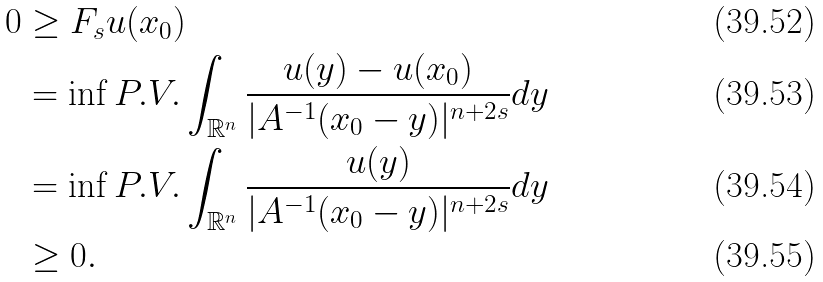<formula> <loc_0><loc_0><loc_500><loc_500>0 & \geq F _ { s } u ( x _ { 0 } ) \\ & = \inf P . V . \int _ { \mathbb { R } ^ { n } } \frac { u ( y ) - u ( x _ { 0 } ) } { | A ^ { - 1 } ( x _ { 0 } - y ) | ^ { n + 2 s } } d y \\ & = \inf P . V . \int _ { \mathbb { R } ^ { n } } \frac { u ( y ) } { | A ^ { - 1 } ( x _ { 0 } - y ) | ^ { n + 2 s } } d y \\ & \geq 0 .</formula> 